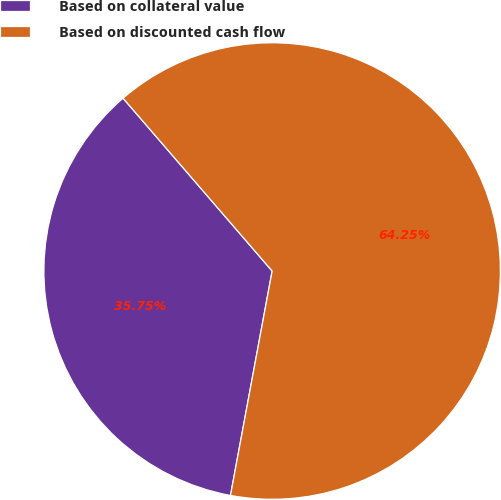Convert chart. <chart><loc_0><loc_0><loc_500><loc_500><pie_chart><fcel>Based on collateral value<fcel>Based on discounted cash flow<nl><fcel>35.75%<fcel>64.25%<nl></chart> 